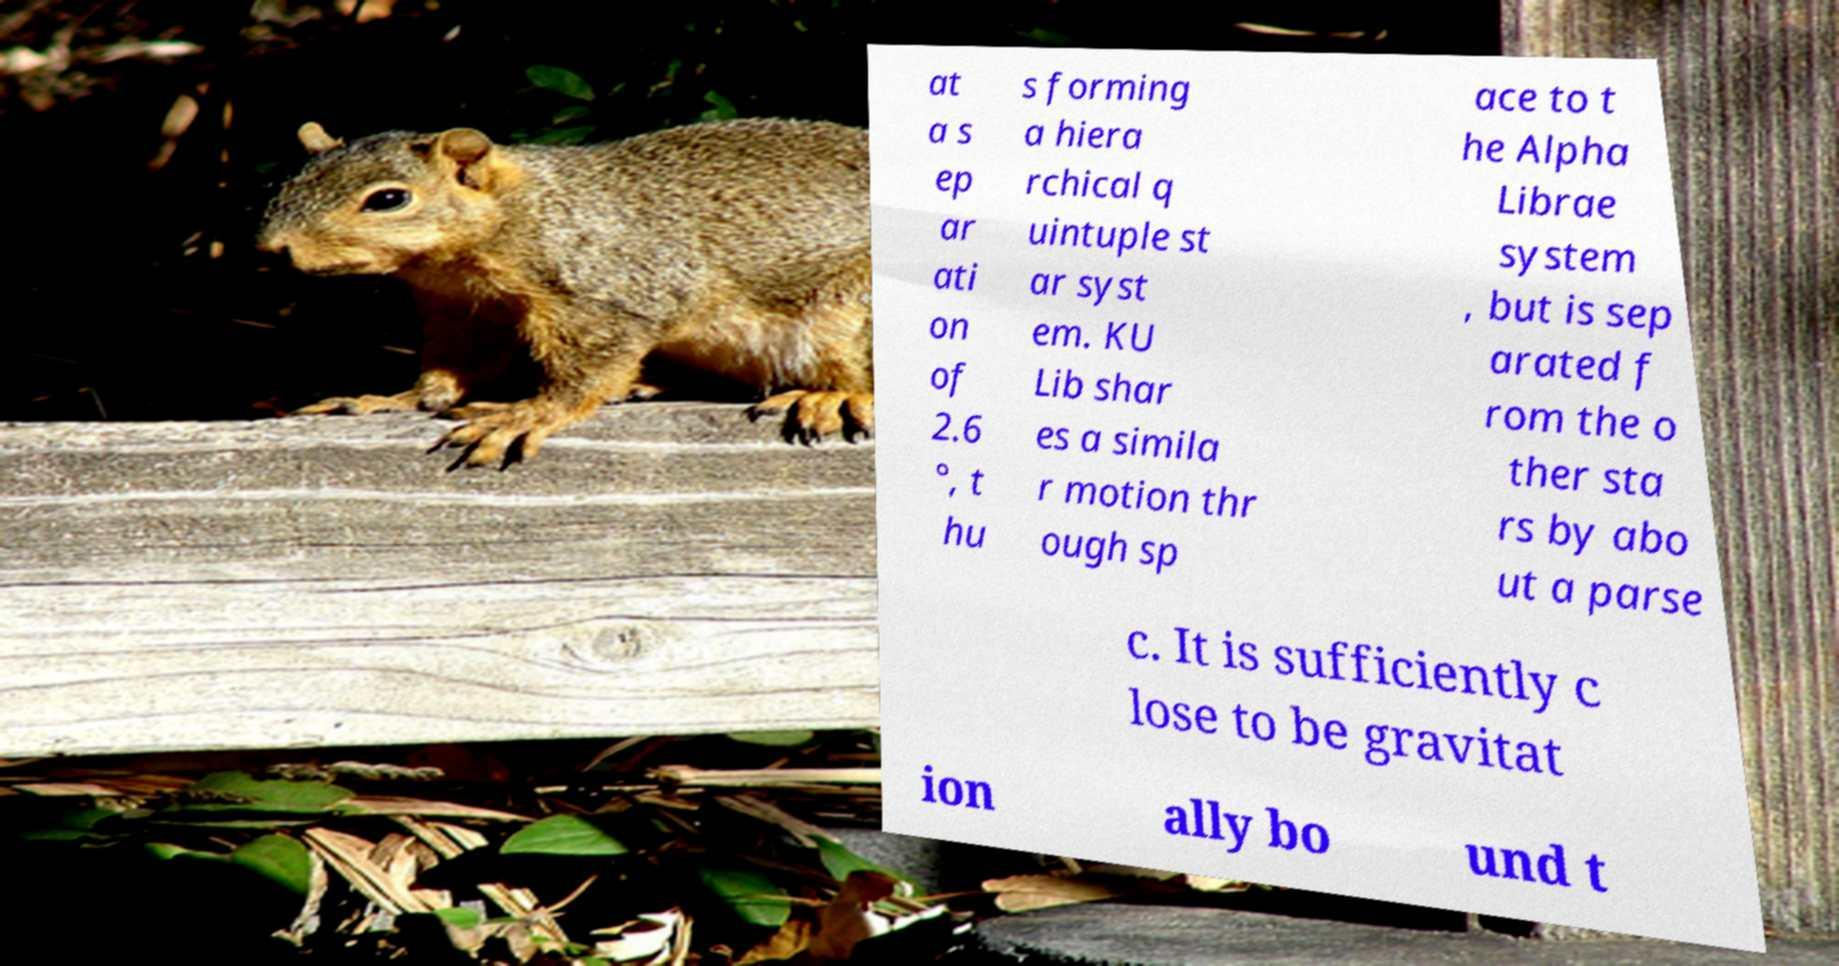There's text embedded in this image that I need extracted. Can you transcribe it verbatim? at a s ep ar ati on of 2.6 °, t hu s forming a hiera rchical q uintuple st ar syst em. KU Lib shar es a simila r motion thr ough sp ace to t he Alpha Librae system , but is sep arated f rom the o ther sta rs by abo ut a parse c. It is sufficiently c lose to be gravitat ion ally bo und t 